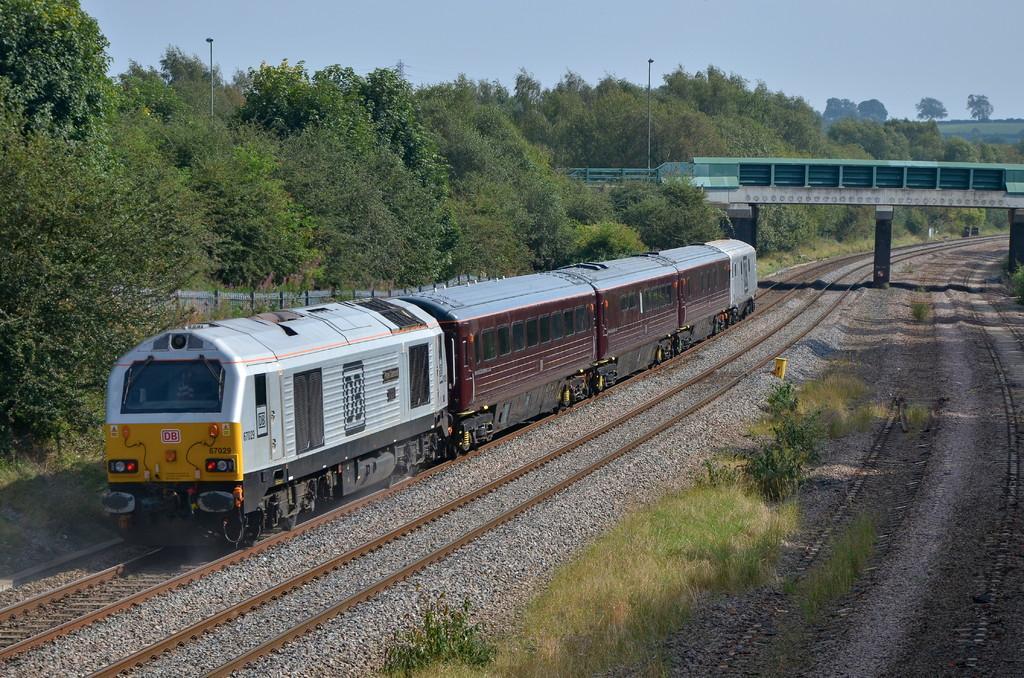How would you summarize this image in a sentence or two? In this image, we can see the railway tracks, there is a train on the track, we can see the bridge, there are some green trees, we can see the poles, at the top there is a sky. 